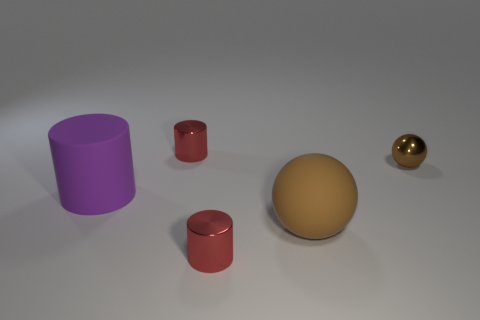There is another object that is the same shape as the brown metal thing; what is its material?
Ensure brevity in your answer.  Rubber. There is a red metallic cylinder behind the big rubber thing behind the large brown object; is there a red metal thing on the left side of it?
Make the answer very short. No. There is a red object in front of the big sphere; is its shape the same as the thing that is behind the tiny brown object?
Offer a very short reply. Yes. Is the number of big balls on the left side of the rubber sphere greater than the number of rubber cylinders?
Make the answer very short. No. How many objects are small metal spheres or metal objects?
Ensure brevity in your answer.  3. The metal sphere is what color?
Your response must be concise. Brown. What number of other things are the same color as the metal ball?
Ensure brevity in your answer.  1. There is a large rubber cylinder; are there any small red metal cylinders to the right of it?
Keep it short and to the point. Yes. What color is the small cylinder in front of the small ball that is right of the thing that is in front of the matte ball?
Offer a very short reply. Red. How many large things are both in front of the large matte cylinder and behind the big brown rubber thing?
Give a very brief answer. 0. 